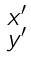Convert formula to latex. <formula><loc_0><loc_0><loc_500><loc_500>\begin{smallmatrix} x ^ { \prime } \\ y ^ { \prime } \end{smallmatrix}</formula> 